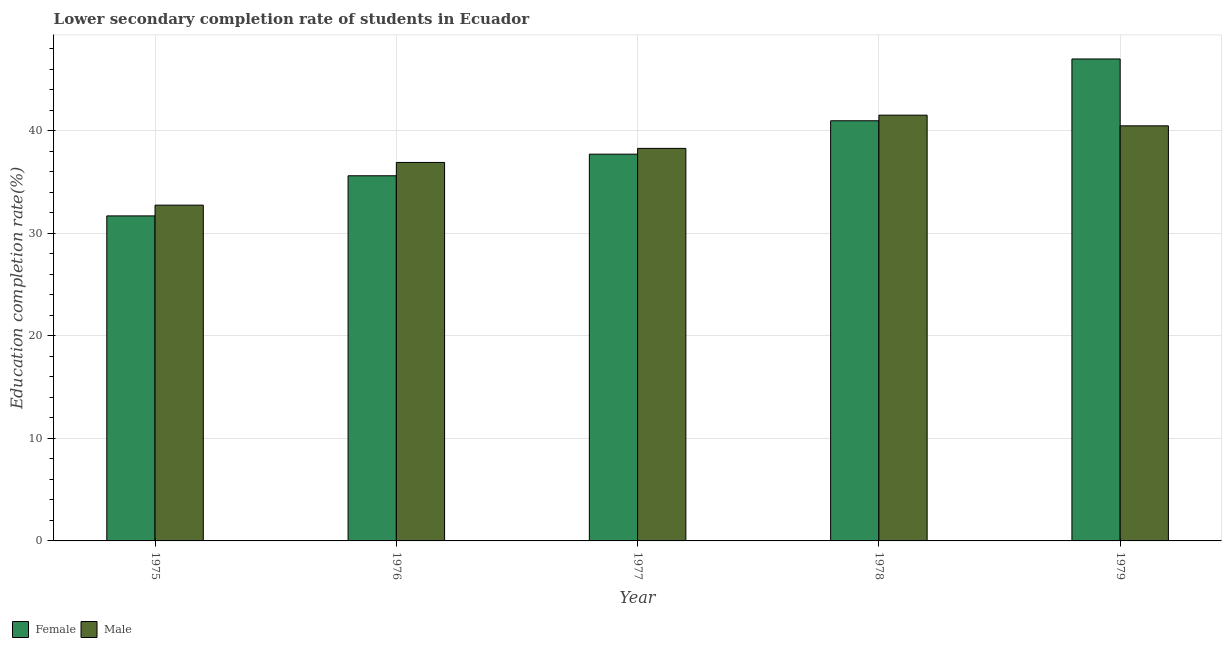How many groups of bars are there?
Give a very brief answer. 5. How many bars are there on the 2nd tick from the left?
Provide a short and direct response. 2. What is the label of the 2nd group of bars from the left?
Offer a terse response. 1976. What is the education completion rate of male students in 1977?
Keep it short and to the point. 38.28. Across all years, what is the maximum education completion rate of male students?
Provide a succinct answer. 41.52. Across all years, what is the minimum education completion rate of female students?
Your answer should be very brief. 31.7. In which year was the education completion rate of female students maximum?
Your answer should be compact. 1979. In which year was the education completion rate of female students minimum?
Ensure brevity in your answer.  1975. What is the total education completion rate of female students in the graph?
Offer a terse response. 193.01. What is the difference between the education completion rate of female students in 1975 and that in 1978?
Give a very brief answer. -9.28. What is the difference between the education completion rate of male students in 1975 and the education completion rate of female students in 1978?
Ensure brevity in your answer.  -8.78. What is the average education completion rate of female students per year?
Give a very brief answer. 38.6. In the year 1976, what is the difference between the education completion rate of male students and education completion rate of female students?
Ensure brevity in your answer.  0. In how many years, is the education completion rate of female students greater than 22 %?
Give a very brief answer. 5. What is the ratio of the education completion rate of male students in 1976 to that in 1979?
Provide a succinct answer. 0.91. What is the difference between the highest and the second highest education completion rate of female students?
Your answer should be compact. 6.03. What is the difference between the highest and the lowest education completion rate of female students?
Provide a succinct answer. 15.3. What does the 1st bar from the left in 1978 represents?
Keep it short and to the point. Female. Are all the bars in the graph horizontal?
Offer a terse response. No. What is the difference between two consecutive major ticks on the Y-axis?
Offer a terse response. 10. How are the legend labels stacked?
Give a very brief answer. Horizontal. What is the title of the graph?
Make the answer very short. Lower secondary completion rate of students in Ecuador. Does "% of gross capital formation" appear as one of the legend labels in the graph?
Give a very brief answer. No. What is the label or title of the Y-axis?
Make the answer very short. Education completion rate(%). What is the Education completion rate(%) of Female in 1975?
Make the answer very short. 31.7. What is the Education completion rate(%) of Male in 1975?
Provide a short and direct response. 32.75. What is the Education completion rate(%) of Female in 1976?
Offer a terse response. 35.61. What is the Education completion rate(%) in Male in 1976?
Your answer should be very brief. 36.91. What is the Education completion rate(%) in Female in 1977?
Give a very brief answer. 37.72. What is the Education completion rate(%) of Male in 1977?
Offer a terse response. 38.28. What is the Education completion rate(%) of Female in 1978?
Your answer should be very brief. 40.98. What is the Education completion rate(%) of Male in 1978?
Make the answer very short. 41.52. What is the Education completion rate(%) in Female in 1979?
Your answer should be very brief. 47. What is the Education completion rate(%) in Male in 1979?
Ensure brevity in your answer.  40.48. Across all years, what is the maximum Education completion rate(%) of Female?
Your response must be concise. 47. Across all years, what is the maximum Education completion rate(%) in Male?
Provide a succinct answer. 41.52. Across all years, what is the minimum Education completion rate(%) of Female?
Offer a terse response. 31.7. Across all years, what is the minimum Education completion rate(%) of Male?
Provide a succinct answer. 32.75. What is the total Education completion rate(%) in Female in the graph?
Give a very brief answer. 193.01. What is the total Education completion rate(%) in Male in the graph?
Ensure brevity in your answer.  189.95. What is the difference between the Education completion rate(%) in Female in 1975 and that in 1976?
Your answer should be compact. -3.91. What is the difference between the Education completion rate(%) of Male in 1975 and that in 1976?
Offer a very short reply. -4.17. What is the difference between the Education completion rate(%) of Female in 1975 and that in 1977?
Provide a short and direct response. -6.02. What is the difference between the Education completion rate(%) in Male in 1975 and that in 1977?
Offer a very short reply. -5.54. What is the difference between the Education completion rate(%) of Female in 1975 and that in 1978?
Your answer should be very brief. -9.28. What is the difference between the Education completion rate(%) in Male in 1975 and that in 1978?
Your answer should be compact. -8.78. What is the difference between the Education completion rate(%) of Female in 1975 and that in 1979?
Your answer should be compact. -15.3. What is the difference between the Education completion rate(%) of Male in 1975 and that in 1979?
Your answer should be compact. -7.74. What is the difference between the Education completion rate(%) of Female in 1976 and that in 1977?
Offer a very short reply. -2.11. What is the difference between the Education completion rate(%) of Male in 1976 and that in 1977?
Offer a terse response. -1.37. What is the difference between the Education completion rate(%) of Female in 1976 and that in 1978?
Your answer should be very brief. -5.36. What is the difference between the Education completion rate(%) of Male in 1976 and that in 1978?
Give a very brief answer. -4.61. What is the difference between the Education completion rate(%) in Female in 1976 and that in 1979?
Offer a very short reply. -11.39. What is the difference between the Education completion rate(%) in Male in 1976 and that in 1979?
Provide a short and direct response. -3.57. What is the difference between the Education completion rate(%) of Female in 1977 and that in 1978?
Your response must be concise. -3.26. What is the difference between the Education completion rate(%) of Male in 1977 and that in 1978?
Your response must be concise. -3.24. What is the difference between the Education completion rate(%) of Female in 1977 and that in 1979?
Make the answer very short. -9.28. What is the difference between the Education completion rate(%) in Male in 1977 and that in 1979?
Ensure brevity in your answer.  -2.2. What is the difference between the Education completion rate(%) of Female in 1978 and that in 1979?
Ensure brevity in your answer.  -6.03. What is the difference between the Education completion rate(%) of Male in 1978 and that in 1979?
Offer a terse response. 1.04. What is the difference between the Education completion rate(%) in Female in 1975 and the Education completion rate(%) in Male in 1976?
Keep it short and to the point. -5.21. What is the difference between the Education completion rate(%) in Female in 1975 and the Education completion rate(%) in Male in 1977?
Ensure brevity in your answer.  -6.59. What is the difference between the Education completion rate(%) in Female in 1975 and the Education completion rate(%) in Male in 1978?
Provide a succinct answer. -9.83. What is the difference between the Education completion rate(%) in Female in 1975 and the Education completion rate(%) in Male in 1979?
Offer a very short reply. -8.78. What is the difference between the Education completion rate(%) in Female in 1976 and the Education completion rate(%) in Male in 1977?
Ensure brevity in your answer.  -2.67. What is the difference between the Education completion rate(%) of Female in 1976 and the Education completion rate(%) of Male in 1978?
Ensure brevity in your answer.  -5.91. What is the difference between the Education completion rate(%) of Female in 1976 and the Education completion rate(%) of Male in 1979?
Provide a short and direct response. -4.87. What is the difference between the Education completion rate(%) in Female in 1977 and the Education completion rate(%) in Male in 1978?
Provide a succinct answer. -3.8. What is the difference between the Education completion rate(%) of Female in 1977 and the Education completion rate(%) of Male in 1979?
Offer a very short reply. -2.76. What is the difference between the Education completion rate(%) in Female in 1978 and the Education completion rate(%) in Male in 1979?
Keep it short and to the point. 0.49. What is the average Education completion rate(%) of Female per year?
Your answer should be compact. 38.6. What is the average Education completion rate(%) of Male per year?
Make the answer very short. 37.99. In the year 1975, what is the difference between the Education completion rate(%) of Female and Education completion rate(%) of Male?
Ensure brevity in your answer.  -1.05. In the year 1976, what is the difference between the Education completion rate(%) in Female and Education completion rate(%) in Male?
Ensure brevity in your answer.  -1.3. In the year 1977, what is the difference between the Education completion rate(%) of Female and Education completion rate(%) of Male?
Offer a very short reply. -0.56. In the year 1978, what is the difference between the Education completion rate(%) in Female and Education completion rate(%) in Male?
Ensure brevity in your answer.  -0.55. In the year 1979, what is the difference between the Education completion rate(%) in Female and Education completion rate(%) in Male?
Ensure brevity in your answer.  6.52. What is the ratio of the Education completion rate(%) of Female in 1975 to that in 1976?
Provide a succinct answer. 0.89. What is the ratio of the Education completion rate(%) of Male in 1975 to that in 1976?
Make the answer very short. 0.89. What is the ratio of the Education completion rate(%) of Female in 1975 to that in 1977?
Provide a succinct answer. 0.84. What is the ratio of the Education completion rate(%) in Male in 1975 to that in 1977?
Keep it short and to the point. 0.86. What is the ratio of the Education completion rate(%) in Female in 1975 to that in 1978?
Provide a short and direct response. 0.77. What is the ratio of the Education completion rate(%) of Male in 1975 to that in 1978?
Your answer should be compact. 0.79. What is the ratio of the Education completion rate(%) in Female in 1975 to that in 1979?
Your response must be concise. 0.67. What is the ratio of the Education completion rate(%) in Male in 1975 to that in 1979?
Provide a short and direct response. 0.81. What is the ratio of the Education completion rate(%) in Female in 1976 to that in 1977?
Offer a very short reply. 0.94. What is the ratio of the Education completion rate(%) of Male in 1976 to that in 1977?
Your response must be concise. 0.96. What is the ratio of the Education completion rate(%) of Female in 1976 to that in 1978?
Make the answer very short. 0.87. What is the ratio of the Education completion rate(%) in Male in 1976 to that in 1978?
Your response must be concise. 0.89. What is the ratio of the Education completion rate(%) in Female in 1976 to that in 1979?
Make the answer very short. 0.76. What is the ratio of the Education completion rate(%) in Male in 1976 to that in 1979?
Offer a very short reply. 0.91. What is the ratio of the Education completion rate(%) of Female in 1977 to that in 1978?
Your answer should be very brief. 0.92. What is the ratio of the Education completion rate(%) in Male in 1977 to that in 1978?
Your answer should be very brief. 0.92. What is the ratio of the Education completion rate(%) in Female in 1977 to that in 1979?
Your answer should be very brief. 0.8. What is the ratio of the Education completion rate(%) of Male in 1977 to that in 1979?
Make the answer very short. 0.95. What is the ratio of the Education completion rate(%) of Female in 1978 to that in 1979?
Give a very brief answer. 0.87. What is the ratio of the Education completion rate(%) in Male in 1978 to that in 1979?
Give a very brief answer. 1.03. What is the difference between the highest and the second highest Education completion rate(%) in Female?
Provide a short and direct response. 6.03. What is the difference between the highest and the second highest Education completion rate(%) in Male?
Your answer should be very brief. 1.04. What is the difference between the highest and the lowest Education completion rate(%) in Female?
Provide a short and direct response. 15.3. What is the difference between the highest and the lowest Education completion rate(%) in Male?
Your response must be concise. 8.78. 